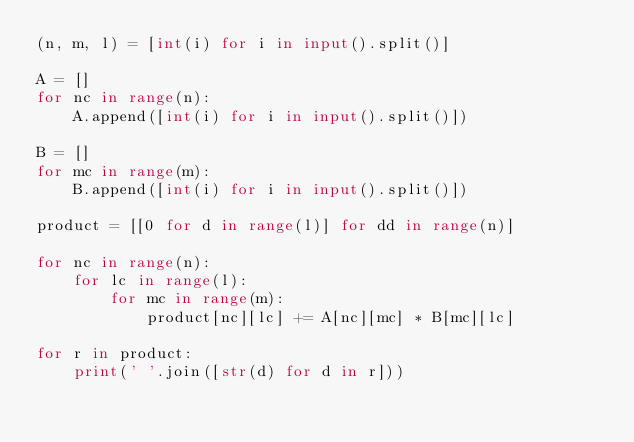Convert code to text. <code><loc_0><loc_0><loc_500><loc_500><_Python_>(n, m, l) = [int(i) for i in input().split()]

A = []
for nc in range(n):
    A.append([int(i) for i in input().split()])

B = []
for mc in range(m):
    B.append([int(i) for i in input().split()])

product = [[0 for d in range(l)] for dd in range(n)]

for nc in range(n):
    for lc in range(l):
        for mc in range(m):
            product[nc][lc] += A[nc][mc] * B[mc][lc]
        
for r in product:
    print(' '.join([str(d) for d in r]))</code> 